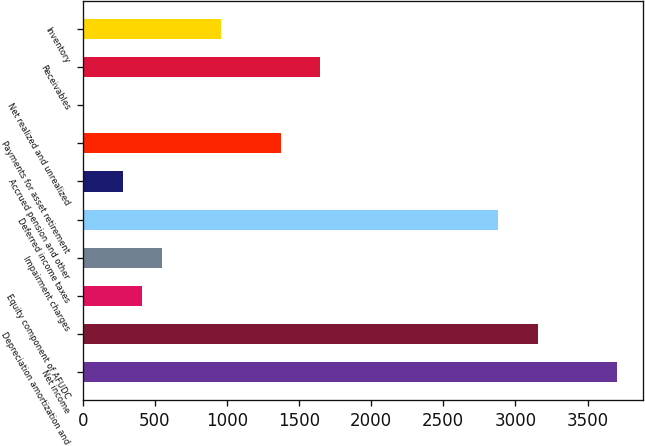<chart> <loc_0><loc_0><loc_500><loc_500><bar_chart><fcel>Net income<fcel>Depreciation amortization and<fcel>Equity component of AFUDC<fcel>Impairment charges<fcel>Deferred income taxes<fcel>Accrued pension and other<fcel>Payments for asset retirement<fcel>Net realized and unrealized<fcel>Receivables<fcel>Inventory<nl><fcel>3702<fcel>3154<fcel>414<fcel>551<fcel>2880<fcel>277<fcel>1373<fcel>3<fcel>1647<fcel>962<nl></chart> 